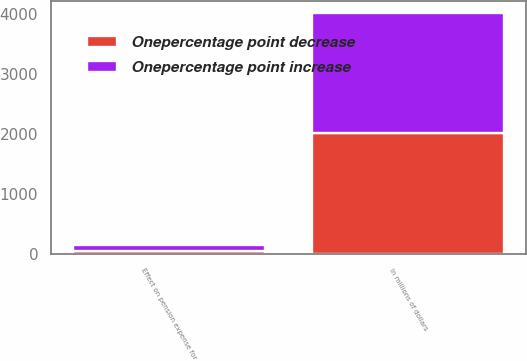Convert chart. <chart><loc_0><loc_0><loc_500><loc_500><stacked_bar_chart><ecel><fcel>In millions of dollars<fcel>Effect on pension expense for<nl><fcel>Onepercentage point decrease<fcel>2008<fcel>58<nl><fcel>Onepercentage point increase<fcel>2008<fcel>94<nl></chart> 